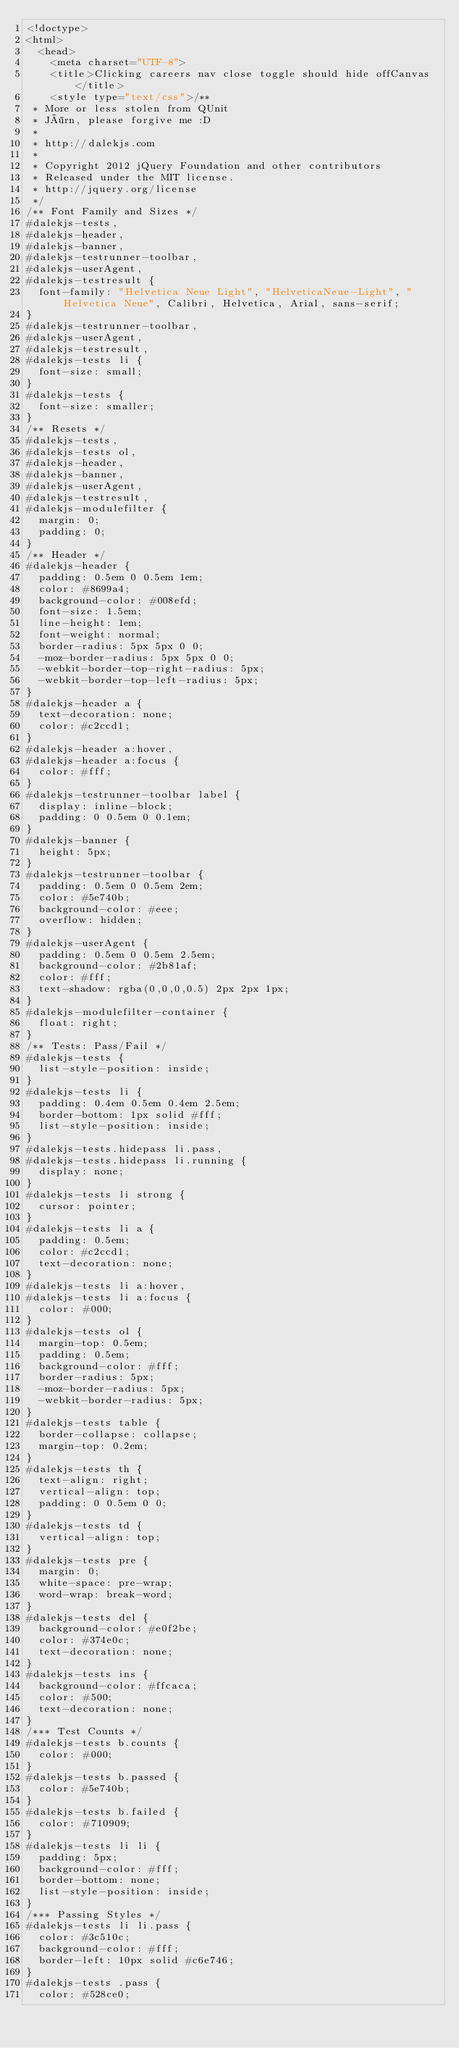<code> <loc_0><loc_0><loc_500><loc_500><_HTML_><!doctype>
<html>
  <head>
    <meta charset="UTF-8">
    <title>Clicking careers nav close toggle should hide offCanvas</title>
    <style type="text/css">/**
 * More or less stolen from QUnit
 * Jörn, please forgive me :D
 *
 * http://dalekjs.com
 *
 * Copyright 2012 jQuery Foundation and other contributors
 * Released under the MIT license.
 * http://jquery.org/license
 */
/** Font Family and Sizes */
#dalekjs-tests,
#dalekjs-header,
#dalekjs-banner,
#dalekjs-testrunner-toolbar,
#dalekjs-userAgent,
#dalekjs-testresult {
  font-family: "Helvetica Neue Light", "HelveticaNeue-Light", "Helvetica Neue", Calibri, Helvetica, Arial, sans-serif;
}
#dalekjs-testrunner-toolbar,
#dalekjs-userAgent,
#dalekjs-testresult,
#dalekjs-tests li {
  font-size: small;
}
#dalekjs-tests {
  font-size: smaller;
}
/** Resets */
#dalekjs-tests,
#dalekjs-tests ol,
#dalekjs-header,
#dalekjs-banner,
#dalekjs-userAgent,
#dalekjs-testresult,
#dalekjs-modulefilter {
  margin: 0;
  padding: 0;
}
/** Header */
#dalekjs-header {
  padding: 0.5em 0 0.5em 1em;
  color: #8699a4;
  background-color: #008efd;
  font-size: 1.5em;
  line-height: 1em;
  font-weight: normal;
  border-radius: 5px 5px 0 0;
  -moz-border-radius: 5px 5px 0 0;
  -webkit-border-top-right-radius: 5px;
  -webkit-border-top-left-radius: 5px;
}
#dalekjs-header a {
  text-decoration: none;
  color: #c2ccd1;
}
#dalekjs-header a:hover,
#dalekjs-header a:focus {
  color: #fff;
}
#dalekjs-testrunner-toolbar label {
  display: inline-block;
  padding: 0 0.5em 0 0.1em;
}
#dalekjs-banner {
  height: 5px;
}
#dalekjs-testrunner-toolbar {
  padding: 0.5em 0 0.5em 2em;
  color: #5e740b;
  background-color: #eee;
  overflow: hidden;
}
#dalekjs-userAgent {
  padding: 0.5em 0 0.5em 2.5em;
  background-color: #2b81af;
  color: #fff;
  text-shadow: rgba(0,0,0,0.5) 2px 2px 1px;
}
#dalekjs-modulefilter-container {
  float: right;
}
/** Tests: Pass/Fail */
#dalekjs-tests {
  list-style-position: inside;
}
#dalekjs-tests li {
  padding: 0.4em 0.5em 0.4em 2.5em;
  border-bottom: 1px solid #fff;
  list-style-position: inside;
}
#dalekjs-tests.hidepass li.pass,
#dalekjs-tests.hidepass li.running {
  display: none;
}
#dalekjs-tests li strong {
  cursor: pointer;
}
#dalekjs-tests li a {
  padding: 0.5em;
  color: #c2ccd1;
  text-decoration: none;
}
#dalekjs-tests li a:hover,
#dalekjs-tests li a:focus {
  color: #000;
}
#dalekjs-tests ol {
  margin-top: 0.5em;
  padding: 0.5em;
  background-color: #fff;
  border-radius: 5px;
  -moz-border-radius: 5px;
  -webkit-border-radius: 5px;
}
#dalekjs-tests table {
  border-collapse: collapse;
  margin-top: 0.2em;
}
#dalekjs-tests th {
  text-align: right;
  vertical-align: top;
  padding: 0 0.5em 0 0;
}
#dalekjs-tests td {
  vertical-align: top;
}
#dalekjs-tests pre {
  margin: 0;
  white-space: pre-wrap;
  word-wrap: break-word;
}
#dalekjs-tests del {
  background-color: #e0f2be;
  color: #374e0c;
  text-decoration: none;
}
#dalekjs-tests ins {
  background-color: #ffcaca;
  color: #500;
  text-decoration: none;
}
/*** Test Counts */
#dalekjs-tests b.counts {
  color: #000;
}
#dalekjs-tests b.passed {
  color: #5e740b;
}
#dalekjs-tests b.failed {
  color: #710909;
}
#dalekjs-tests li li {
  padding: 5px;
  background-color: #fff;
  border-bottom: none;
  list-style-position: inside;
}
/*** Passing Styles */
#dalekjs-tests li li.pass {
  color: #3c510c;
  background-color: #fff;
  border-left: 10px solid #c6e746;
}
#dalekjs-tests .pass {
  color: #528ce0;</code> 